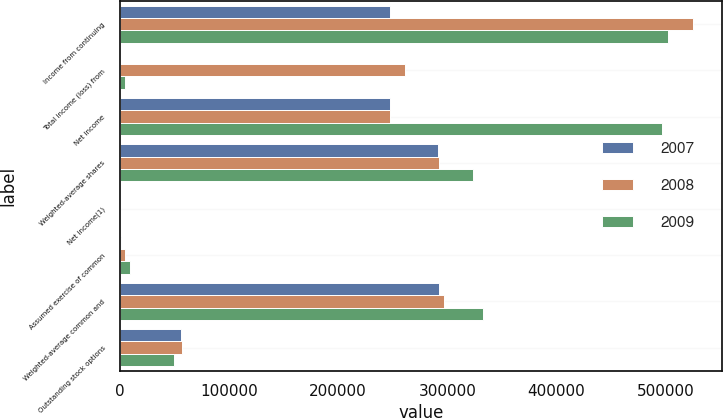Convert chart to OTSL. <chart><loc_0><loc_0><loc_500><loc_500><stacked_bar_chart><ecel><fcel>Income from continuing<fcel>Total income (loss) from<fcel>Net income<fcel>Weighted-average shares<fcel>Net income(1)<fcel>Assumed exercise of common<fcel>Weighted-average common and<fcel>Outstanding stock options<nl><fcel>2007<fcel>247408<fcel>364<fcel>247772<fcel>291385<fcel>0.85<fcel>1313<fcel>292698<fcel>55827<nl><fcel>2008<fcel>525177<fcel>261107<fcel>247408<fcel>292688<fcel>2.69<fcel>4422<fcel>297110<fcel>57364<nl><fcel>2009<fcel>502123<fcel>5216<fcel>496907<fcel>323255<fcel>1.54<fcel>9046<fcel>332301<fcel>49915<nl></chart> 